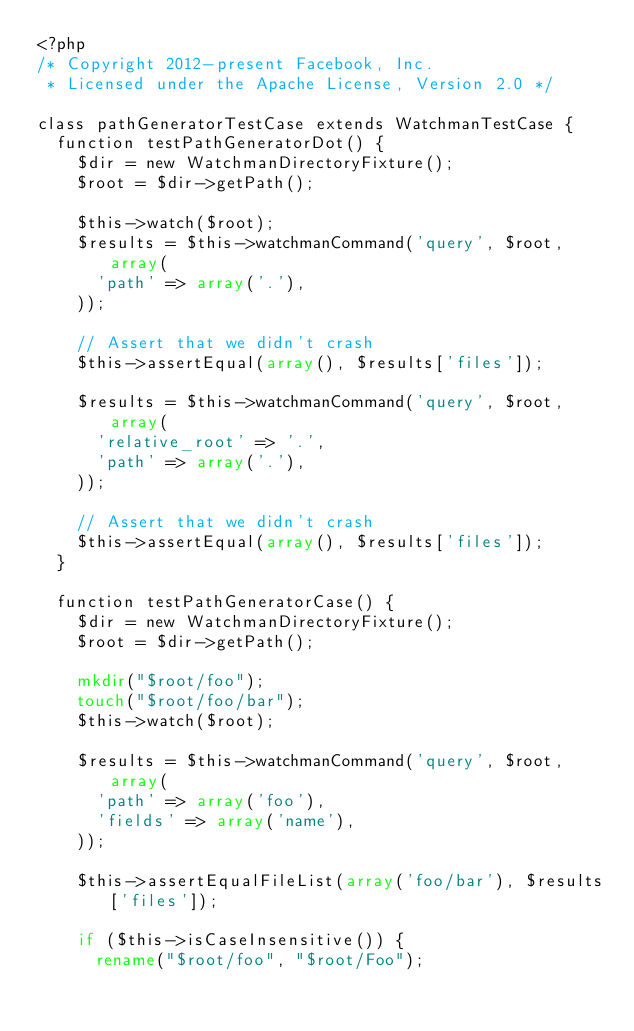<code> <loc_0><loc_0><loc_500><loc_500><_PHP_><?php
/* Copyright 2012-present Facebook, Inc.
 * Licensed under the Apache License, Version 2.0 */

class pathGeneratorTestCase extends WatchmanTestCase {
  function testPathGeneratorDot() {
    $dir = new WatchmanDirectoryFixture();
    $root = $dir->getPath();

    $this->watch($root);
    $results = $this->watchmanCommand('query', $root, array(
      'path' => array('.'),
    ));

    // Assert that we didn't crash
    $this->assertEqual(array(), $results['files']);

    $results = $this->watchmanCommand('query', $root, array(
      'relative_root' => '.',
      'path' => array('.'),
    ));

    // Assert that we didn't crash
    $this->assertEqual(array(), $results['files']);
  }

  function testPathGeneratorCase() {
    $dir = new WatchmanDirectoryFixture();
    $root = $dir->getPath();

    mkdir("$root/foo");
    touch("$root/foo/bar");
    $this->watch($root);

    $results = $this->watchmanCommand('query', $root, array(
      'path' => array('foo'),
      'fields' => array('name'),
    ));

    $this->assertEqualFileList(array('foo/bar'), $results['files']);

    if ($this->isCaseInsensitive()) {
      rename("$root/foo", "$root/Foo");
</code> 